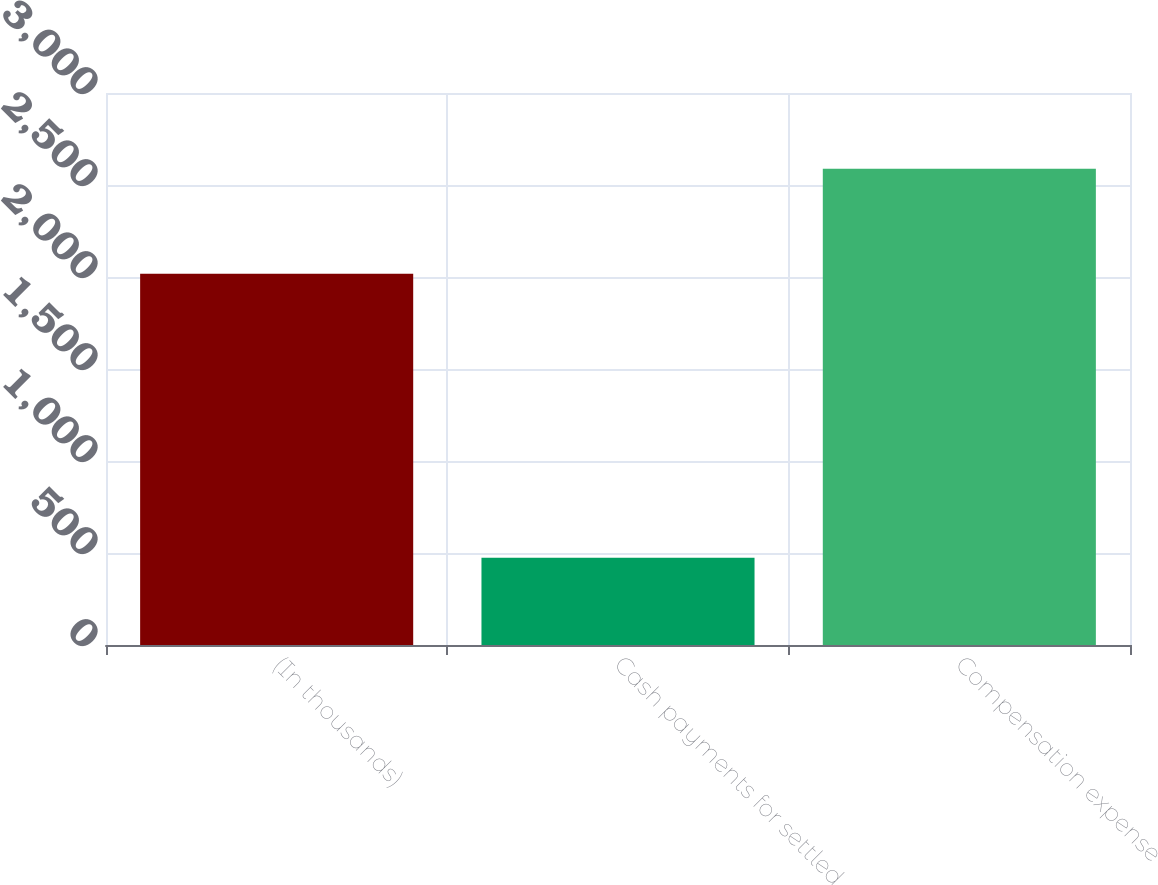<chart> <loc_0><loc_0><loc_500><loc_500><bar_chart><fcel>(In thousands)<fcel>Cash payments for settled<fcel>Compensation expense<nl><fcel>2017<fcel>474<fcel>2588<nl></chart> 